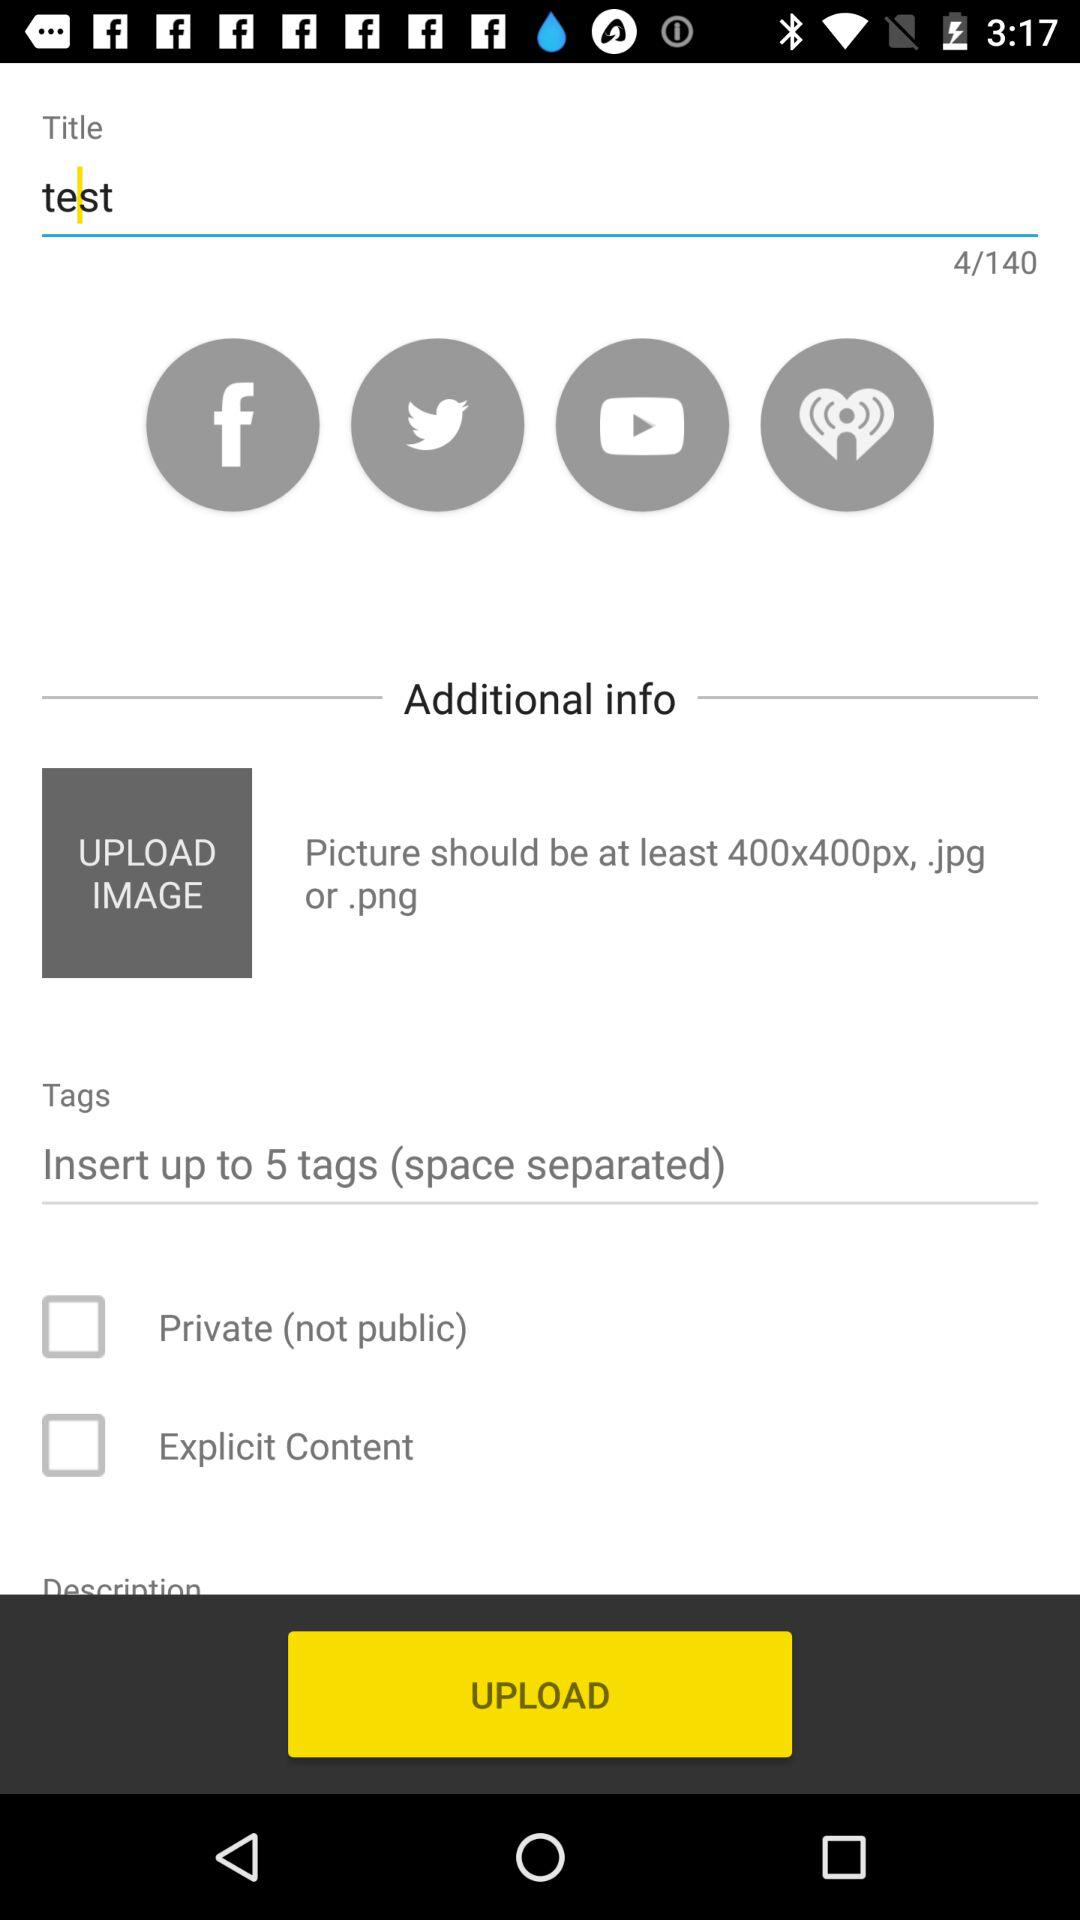What is the given text limit? The given text limit is 140. 